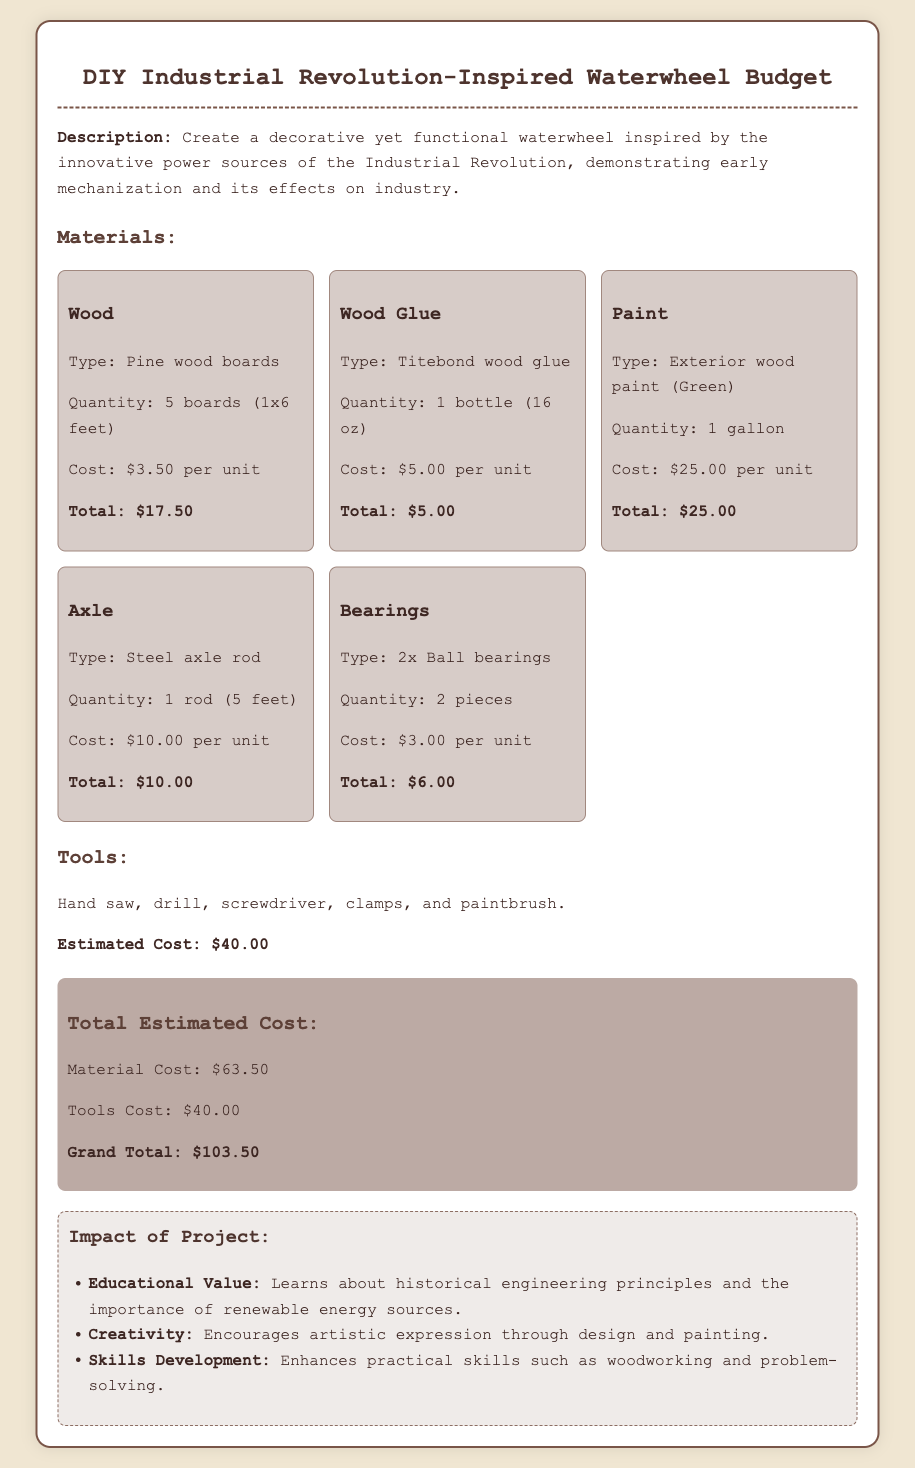what is the total cost of the wood? The total cost of the wood is calculated by multiplying the cost per unit by the quantity, which is $3.50 per board for 5 boards, resulting in $17.50.
Answer: $17.50 what type of paint is used in the project? The document specifies the type of paint as "Exterior wood paint (Green)".
Answer: Exterior wood paint (Green) how many ball bearings are needed? The project requires 2 pieces of ball bearings as indicated in the materials list.
Answer: 2 pieces what is the total estimated cost of tools? The estimated cost of tools is explicitly stated in the document as $40.00.
Answer: $40.00 what is the grand total of the project? The grand total is the sum of material costs and tools costs, which is $63.50 + $40.00 equaling $103.50.
Answer: $103.50 what kind of wood is used for the project? The document specifies that pine wood boards are used for the project.
Answer: Pine wood boards what educational value does this project offer? The document mentions one educational value as learning about historical engineering principles.
Answer: Learns about historical engineering principles how many gallons of paint are required? According to the materials list, only 1 gallon of paint is required for the project.
Answer: 1 gallon what is the main purpose of the waterwheel project? The main purpose is to create a decorative yet functional waterwheel that demonstrates early mechanization.
Answer: Create a decorative yet functional waterwheel 